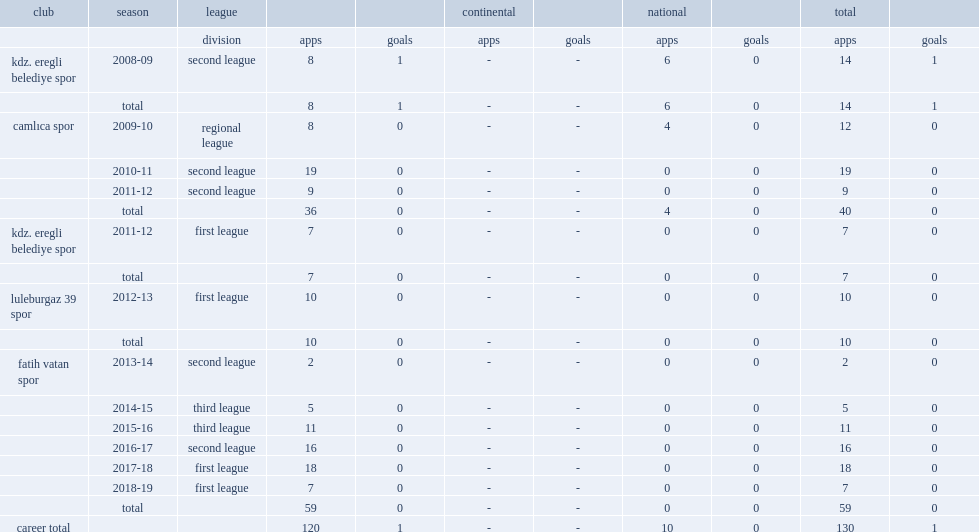Which club did ozlem gezer join in the 2012-13 first league season? Luleburgaz 39 spor. Could you help me parse every detail presented in this table? {'header': ['club', 'season', 'league', '', '', 'continental', '', 'national', '', 'total', ''], 'rows': [['', '', 'division', 'apps', 'goals', 'apps', 'goals', 'apps', 'goals', 'apps', 'goals'], ['kdz. eregli belediye spor', '2008-09', 'second league', '8', '1', '-', '-', '6', '0', '14', '1'], ['', 'total', '', '8', '1', '-', '-', '6', '0', '14', '1'], ['camlıca spor', '2009-10', 'regional league', '8', '0', '-', '-', '4', '0', '12', '0'], ['', '2010-11', 'second league', '19', '0', '-', '-', '0', '0', '19', '0'], ['', '2011-12', 'second league', '9', '0', '-', '-', '0', '0', '9', '0'], ['', 'total', '', '36', '0', '-', '-', '4', '0', '40', '0'], ['kdz. eregli belediye spor', '2011-12', 'first league', '7', '0', '-', '-', '0', '0', '7', '0'], ['', 'total', '', '7', '0', '-', '-', '0', '0', '7', '0'], ['luleburgaz 39 spor', '2012-13', 'first league', '10', '0', '-', '-', '0', '0', '10', '0'], ['', 'total', '', '10', '0', '-', '-', '0', '0', '10', '0'], ['fatih vatan spor', '2013-14', 'second league', '2', '0', '-', '-', '0', '0', '2', '0'], ['', '2014-15', 'third league', '5', '0', '-', '-', '0', '0', '5', '0'], ['', '2015-16', 'third league', '11', '0', '-', '-', '0', '0', '11', '0'], ['', '2016-17', 'second league', '16', '0', '-', '-', '0', '0', '16', '0'], ['', '2017-18', 'first league', '18', '0', '-', '-', '0', '0', '18', '0'], ['', '2018-19', 'first league', '7', '0', '-', '-', '0', '0', '7', '0'], ['', 'total', '', '59', '0', '-', '-', '0', '0', '59', '0'], ['career total', '', '', '120', '1', '-', '-', '10', '0', '130', '1']]} 